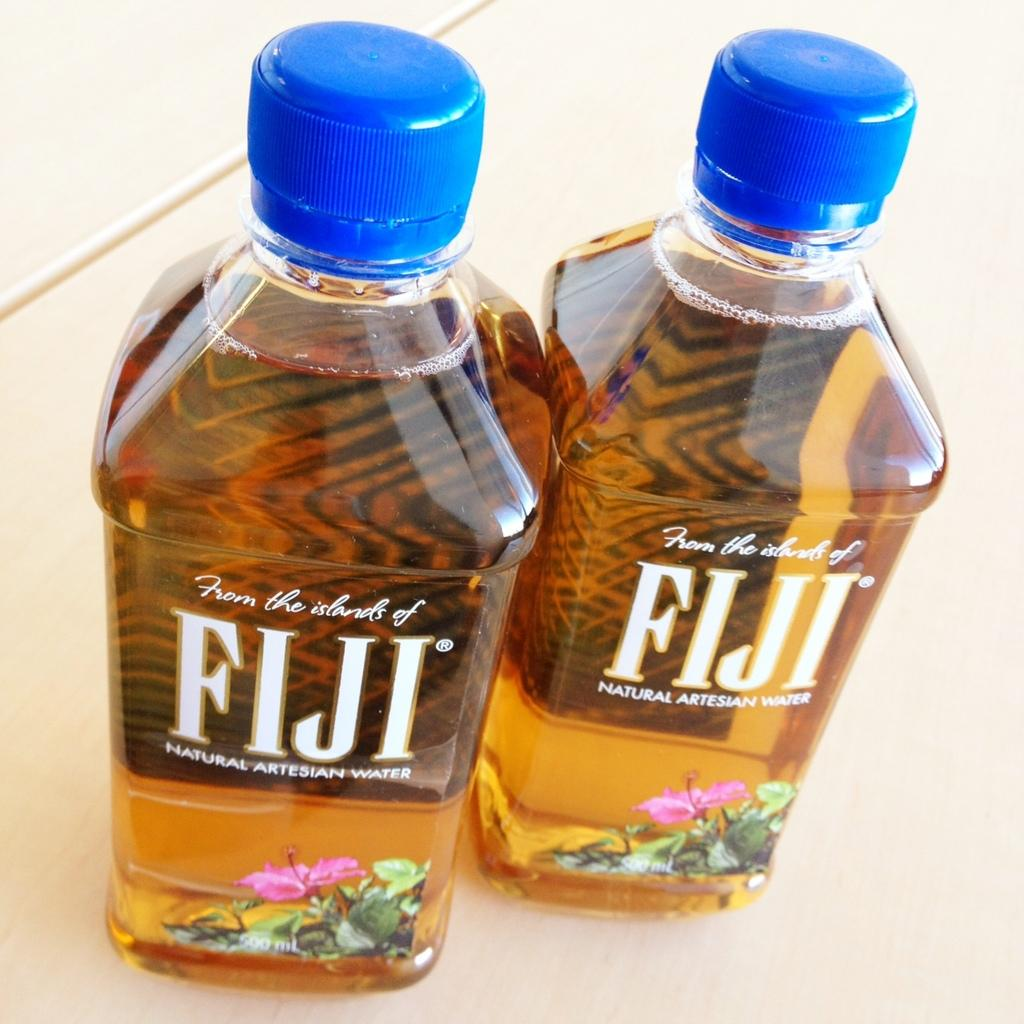<image>
Write a terse but informative summary of the picture. Two new bottles of water have the brand name Fiji on them. 